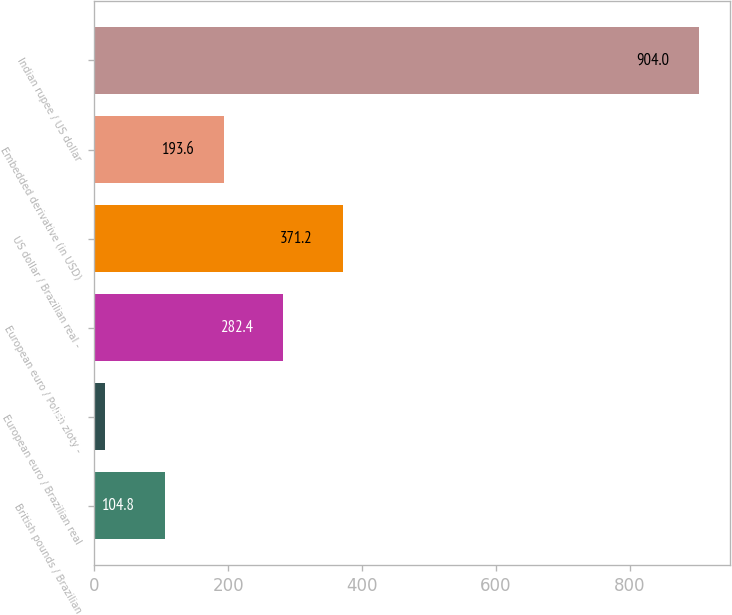<chart> <loc_0><loc_0><loc_500><loc_500><bar_chart><fcel>British pounds / Brazilian<fcel>European euro / Brazilian real<fcel>European euro / Polish zloty -<fcel>US dollar / Brazilian real -<fcel>Embedded derivative (in USD)<fcel>Indian rupee / US dollar<nl><fcel>104.8<fcel>16<fcel>282.4<fcel>371.2<fcel>193.6<fcel>904<nl></chart> 